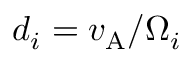<formula> <loc_0><loc_0><loc_500><loc_500>d _ { i } = v _ { A } / \Omega _ { i }</formula> 